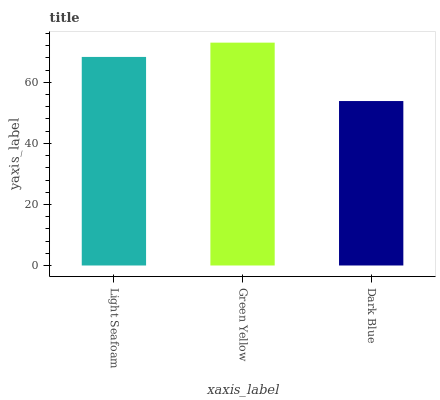Is Dark Blue the minimum?
Answer yes or no. Yes. Is Green Yellow the maximum?
Answer yes or no. Yes. Is Green Yellow the minimum?
Answer yes or no. No. Is Dark Blue the maximum?
Answer yes or no. No. Is Green Yellow greater than Dark Blue?
Answer yes or no. Yes. Is Dark Blue less than Green Yellow?
Answer yes or no. Yes. Is Dark Blue greater than Green Yellow?
Answer yes or no. No. Is Green Yellow less than Dark Blue?
Answer yes or no. No. Is Light Seafoam the high median?
Answer yes or no. Yes. Is Light Seafoam the low median?
Answer yes or no. Yes. Is Dark Blue the high median?
Answer yes or no. No. Is Green Yellow the low median?
Answer yes or no. No. 